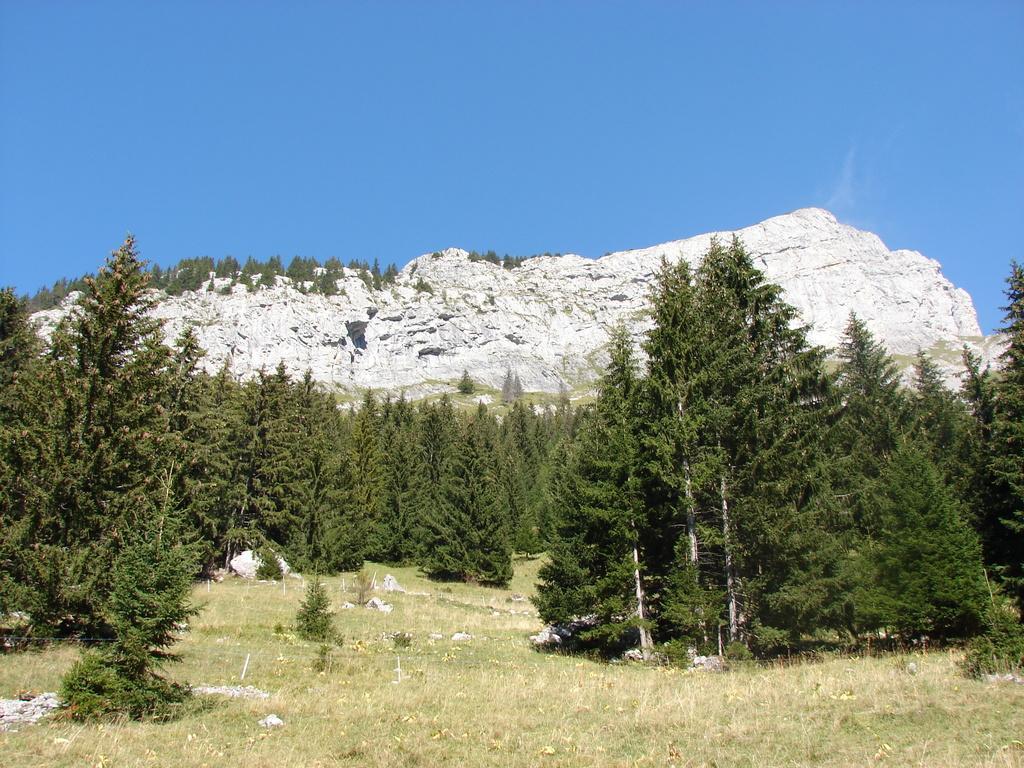How would you summarize this image in a sentence or two? In this image there are trees, grass, mountains and sky. 